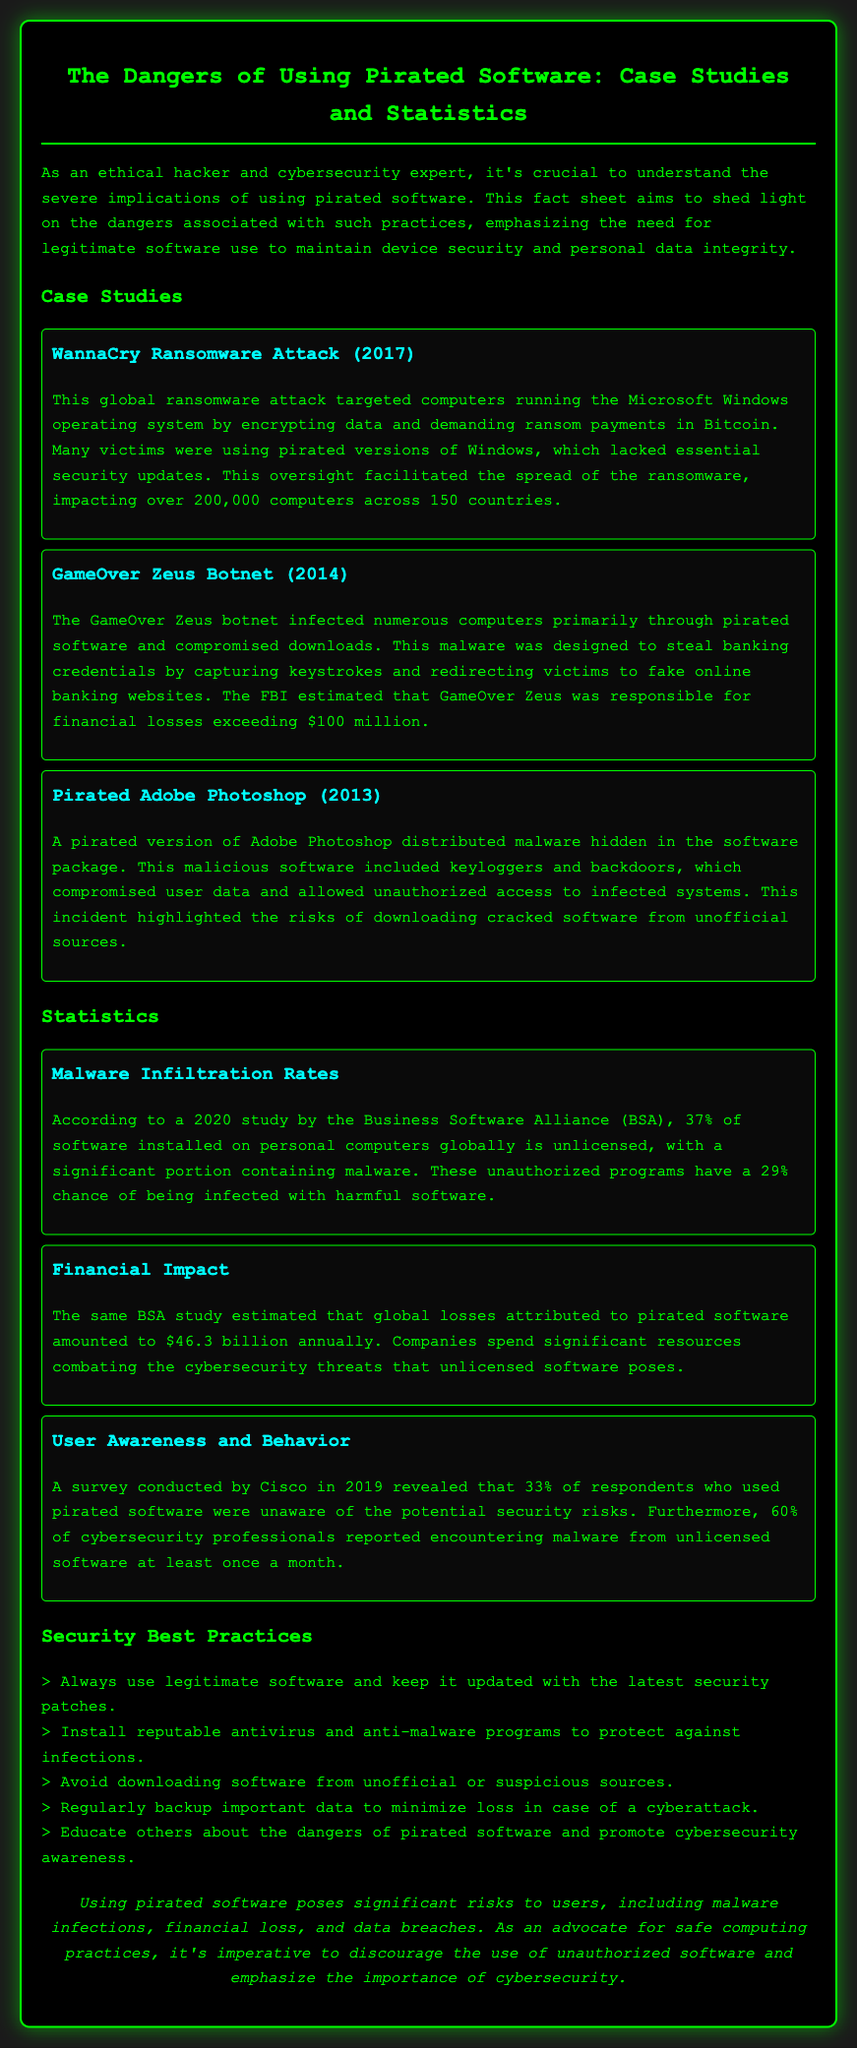What was the impact of the WannaCry attack? The WannaCry attack affected over 200,000 computers across 150 countries due to the use of pirated software.
Answer: over 200,000 computers What percentage of installed software is unlicensed according to the 2020 BSA study? The BSA study states that 37% of software installed on personal computers globally is unlicensed.
Answer: 37% What financial losses are attributed to pirated software annually? The BSA study estimated that global losses attributed to pirated software amounted to $46.3 billion annually.
Answer: $46.3 billion What security risk is highlighted in the case of pirated Adobe Photoshop? The pirated version of Adobe Photoshop distributed malware, including keyloggers and backdoors.
Answer: malware What was a major method of infection for the GameOver Zeus botnet? The GameOver Zeus botnet primarily infected computers through pirated software and compromised downloads.
Answer: pirated software What percentage of cybersecurity professionals encounter malware from unlicensed software? According to the survey, 60% of cybersecurity professionals reported encountering malware from unlicensed software at least once a month.
Answer: 60% What is one security best practice mentioned in the document? The document lists several best practices, including always using legitimate software and keeping it updated.
Answer: use legitimate software What year did the WannaCry ransomware attack occur? The WannaCry ransomware attack took place in 2017.
Answer: 2017 What is the primary focus of the fact sheet? The fact sheet focuses on the dangers associated with using pirated software and its impact on cybersecurity.
Answer: dangers of using pirated software 